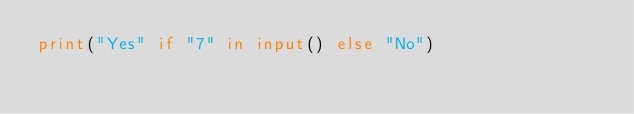Convert code to text. <code><loc_0><loc_0><loc_500><loc_500><_Python_>print("Yes" if "7" in input() else "No")</code> 